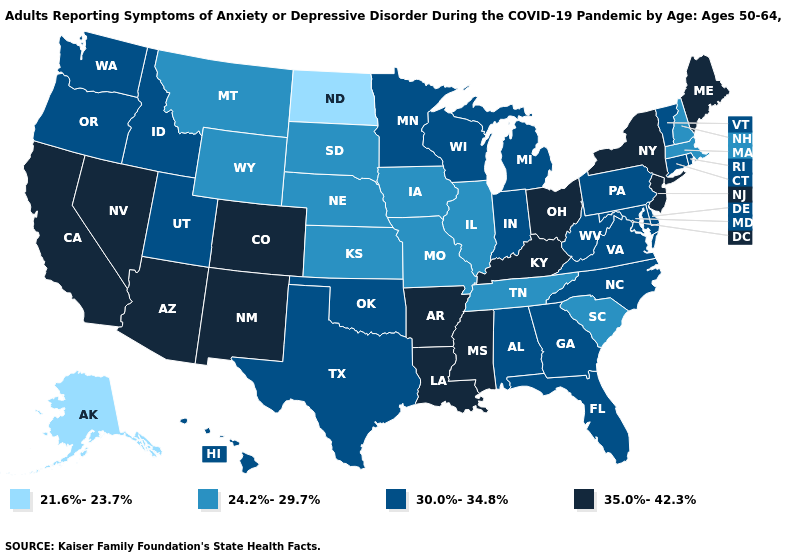Does the first symbol in the legend represent the smallest category?
Short answer required. Yes. Name the states that have a value in the range 35.0%-42.3%?
Concise answer only. Arizona, Arkansas, California, Colorado, Kentucky, Louisiana, Maine, Mississippi, Nevada, New Jersey, New Mexico, New York, Ohio. Name the states that have a value in the range 21.6%-23.7%?
Short answer required. Alaska, North Dakota. What is the lowest value in the Northeast?
Quick response, please. 24.2%-29.7%. What is the value of South Dakota?
Give a very brief answer. 24.2%-29.7%. What is the highest value in states that border Pennsylvania?
Give a very brief answer. 35.0%-42.3%. What is the value of Tennessee?
Be succinct. 24.2%-29.7%. Among the states that border Maine , which have the highest value?
Short answer required. New Hampshire. What is the value of Minnesota?
Write a very short answer. 30.0%-34.8%. What is the value of Rhode Island?
Write a very short answer. 30.0%-34.8%. Name the states that have a value in the range 35.0%-42.3%?
Answer briefly. Arizona, Arkansas, California, Colorado, Kentucky, Louisiana, Maine, Mississippi, Nevada, New Jersey, New Mexico, New York, Ohio. Among the states that border South Dakota , does Nebraska have the highest value?
Keep it brief. No. Does the first symbol in the legend represent the smallest category?
Write a very short answer. Yes. What is the value of Tennessee?
Keep it brief. 24.2%-29.7%. Which states have the lowest value in the Northeast?
Give a very brief answer. Massachusetts, New Hampshire. 